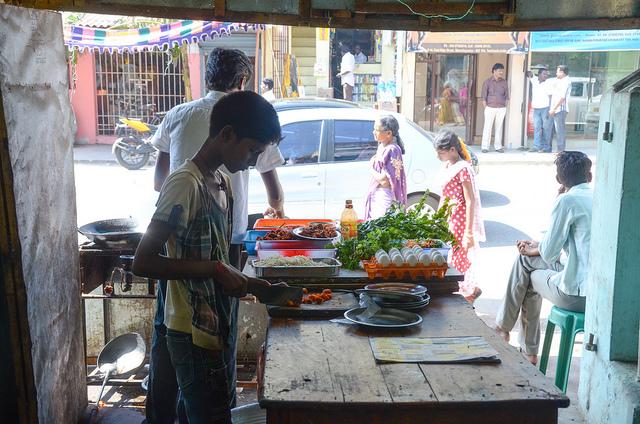How many people are in the picture?
Give a very brief answer. 10. Is this a restaurant?
Give a very brief answer. No. What is the kid chopping?
Short answer required. Carrots. Is it sunny?
Be succinct. Yes. 